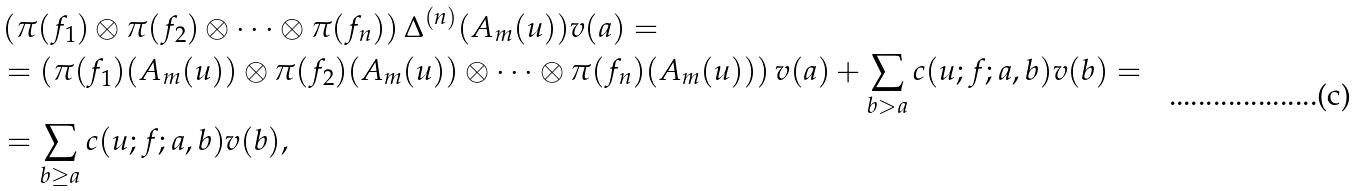<formula> <loc_0><loc_0><loc_500><loc_500>& \left ( \pi ( f _ { 1 } ) \otimes \pi ( f _ { 2 } ) \otimes \cdots \otimes \pi ( f _ { n } ) \right ) \Delta ^ { ( n ) } ( A _ { m } ( u ) ) v ( a ) = \\ & = \left ( \pi ( f _ { 1 } ) ( A _ { m } ( u ) ) \otimes \pi ( f _ { 2 } ) ( A _ { m } ( u ) ) \otimes \cdots \otimes \pi ( f _ { n } ) ( A _ { m } ( u ) ) \right ) v ( a ) + \sum _ { b > a } c ( u ; f ; a , b ) v ( b ) = \\ & = \sum _ { b \geq a } c ( u ; f ; a , b ) v ( b ) ,</formula> 